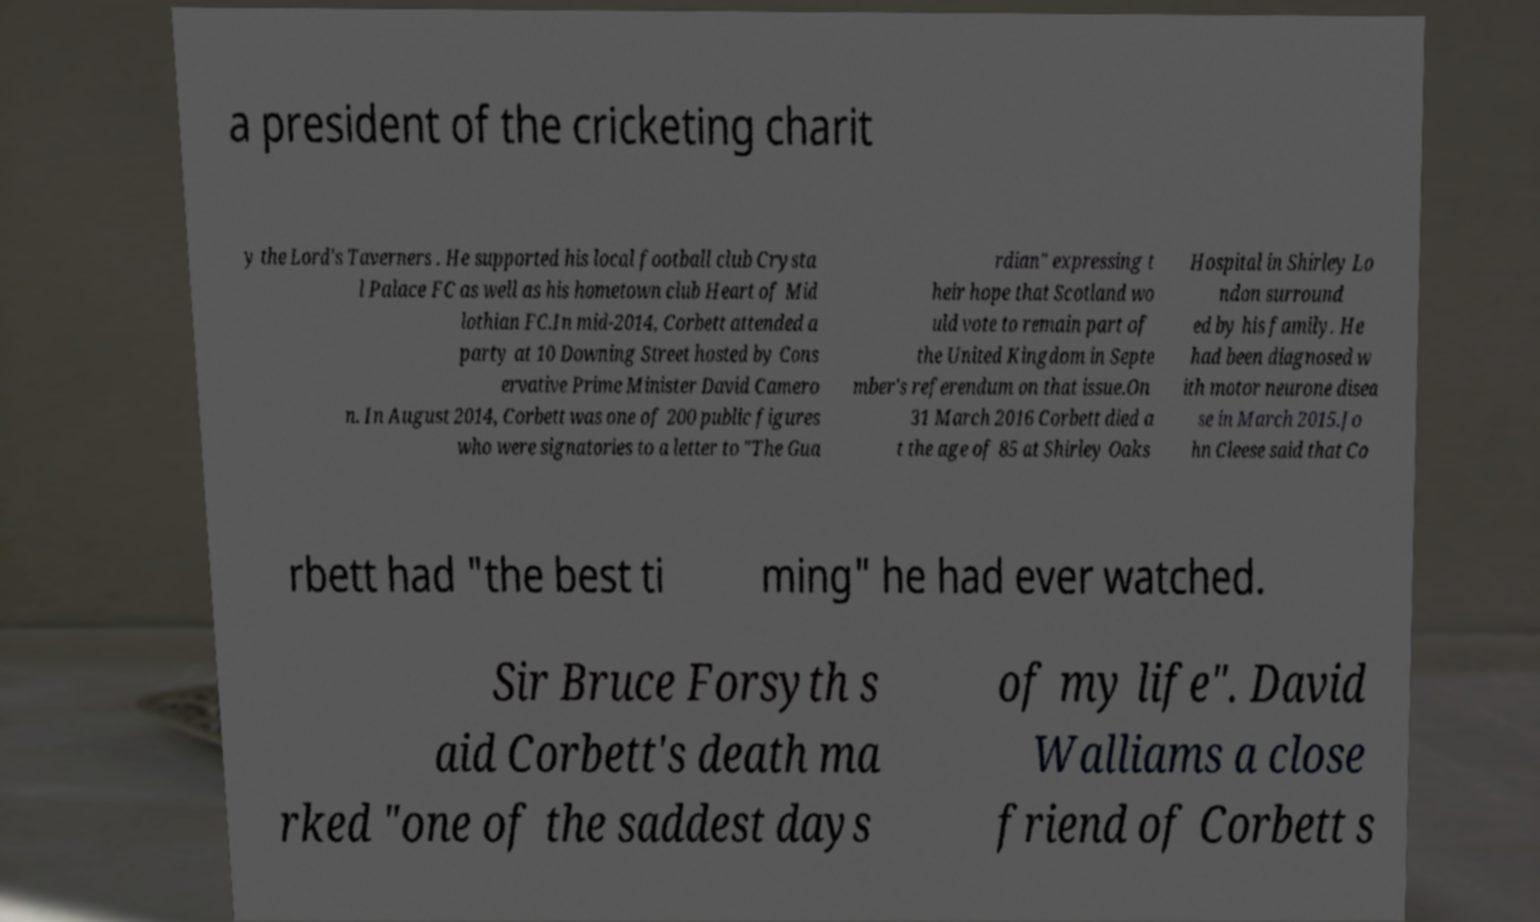For documentation purposes, I need the text within this image transcribed. Could you provide that? a president of the cricketing charit y the Lord's Taverners . He supported his local football club Crysta l Palace FC as well as his hometown club Heart of Mid lothian FC.In mid-2014, Corbett attended a party at 10 Downing Street hosted by Cons ervative Prime Minister David Camero n. In August 2014, Corbett was one of 200 public figures who were signatories to a letter to "The Gua rdian" expressing t heir hope that Scotland wo uld vote to remain part of the United Kingdom in Septe mber's referendum on that issue.On 31 March 2016 Corbett died a t the age of 85 at Shirley Oaks Hospital in Shirley Lo ndon surround ed by his family. He had been diagnosed w ith motor neurone disea se in March 2015.Jo hn Cleese said that Co rbett had "the best ti ming" he had ever watched. Sir Bruce Forsyth s aid Corbett's death ma rked "one of the saddest days of my life". David Walliams a close friend of Corbett s 